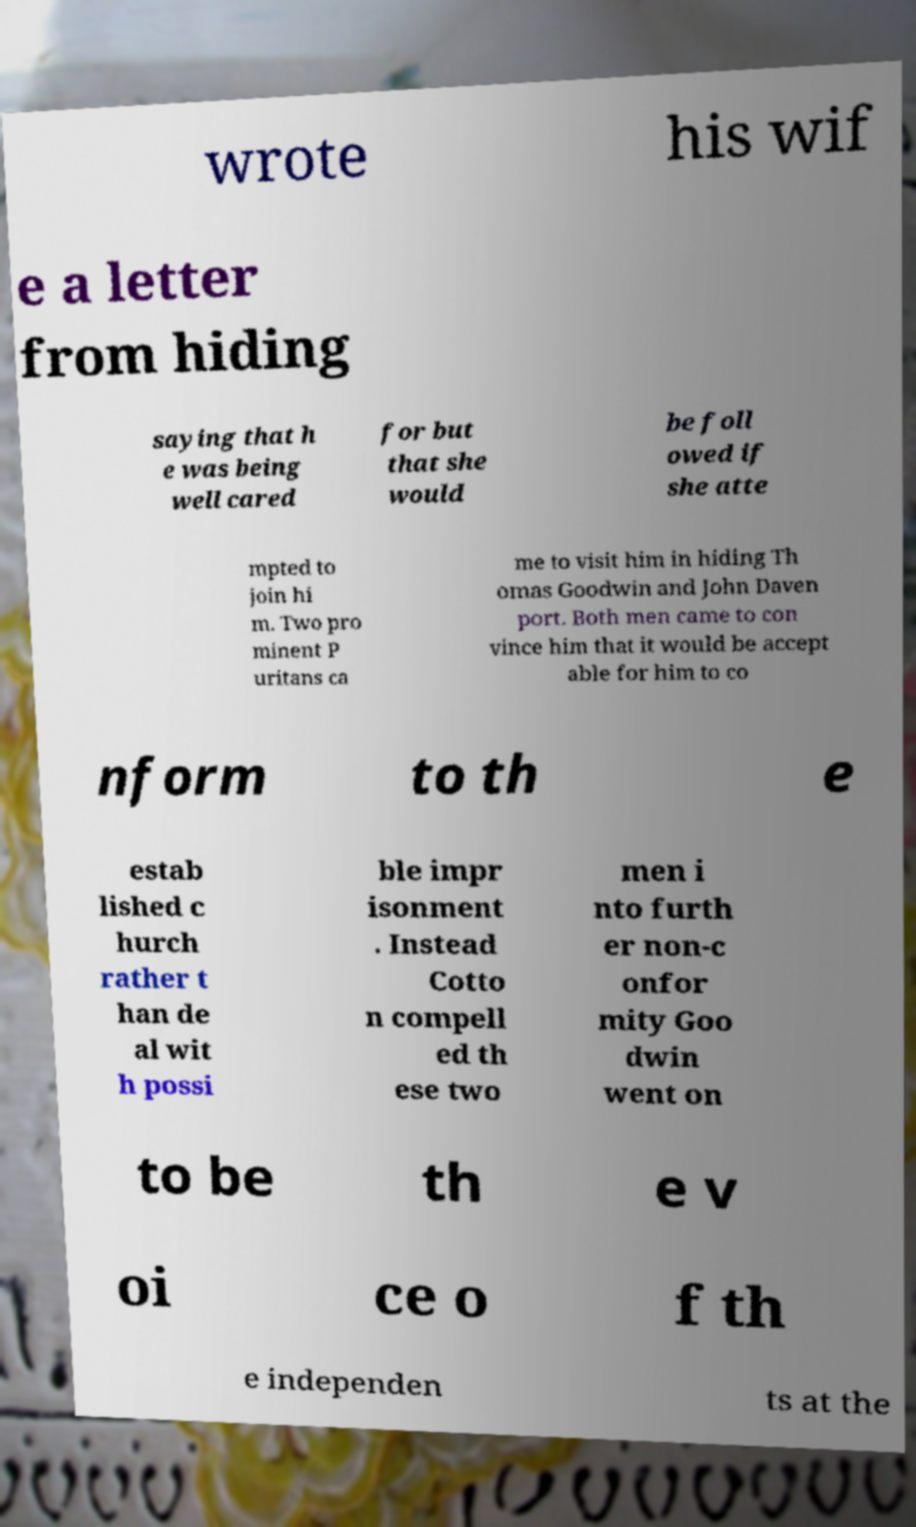For documentation purposes, I need the text within this image transcribed. Could you provide that? wrote his wif e a letter from hiding saying that h e was being well cared for but that she would be foll owed if she atte mpted to join hi m. Two pro minent P uritans ca me to visit him in hiding Th omas Goodwin and John Daven port. Both men came to con vince him that it would be accept able for him to co nform to th e estab lished c hurch rather t han de al wit h possi ble impr isonment . Instead Cotto n compell ed th ese two men i nto furth er non-c onfor mity Goo dwin went on to be th e v oi ce o f th e independen ts at the 